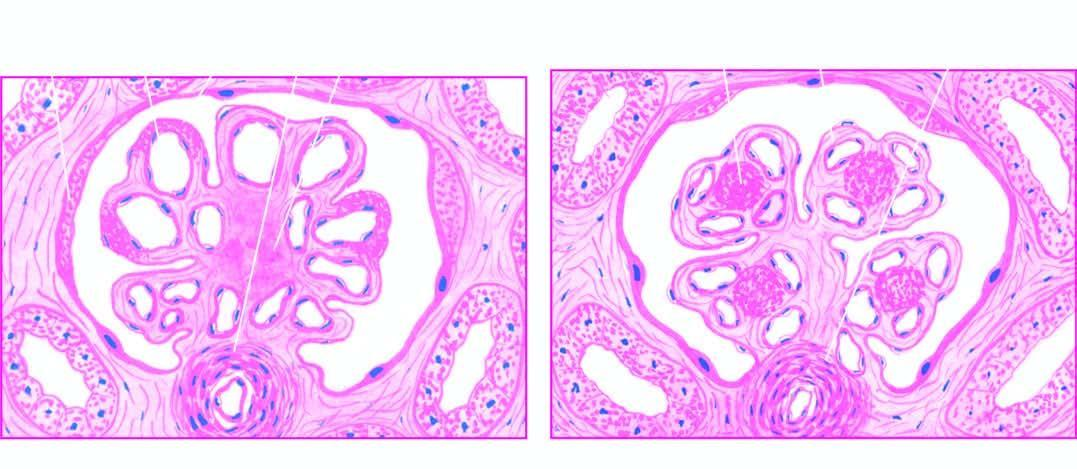what are there within the lobules of glomeruli, surrounded peripherally by glomerular capillaries with thickened walls?
Answer the question using a single word or phrase. One or more hyaline nodules 